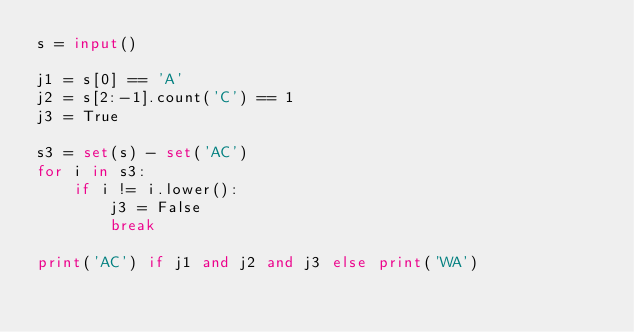Convert code to text. <code><loc_0><loc_0><loc_500><loc_500><_Python_>s = input()

j1 = s[0] == 'A'
j2 = s[2:-1].count('C') == 1
j3 = True

s3 = set(s) - set('AC')
for i in s3:
    if i != i.lower():
        j3 = False
        break

print('AC') if j1 and j2 and j3 else print('WA')</code> 